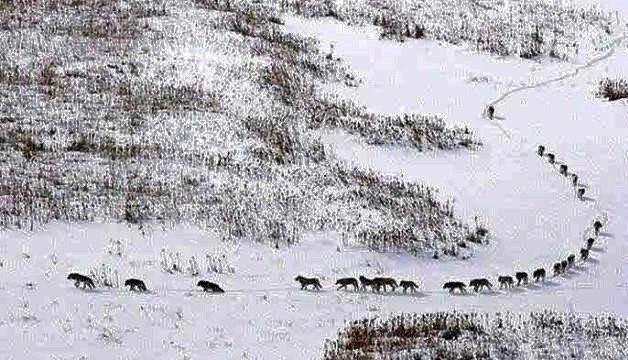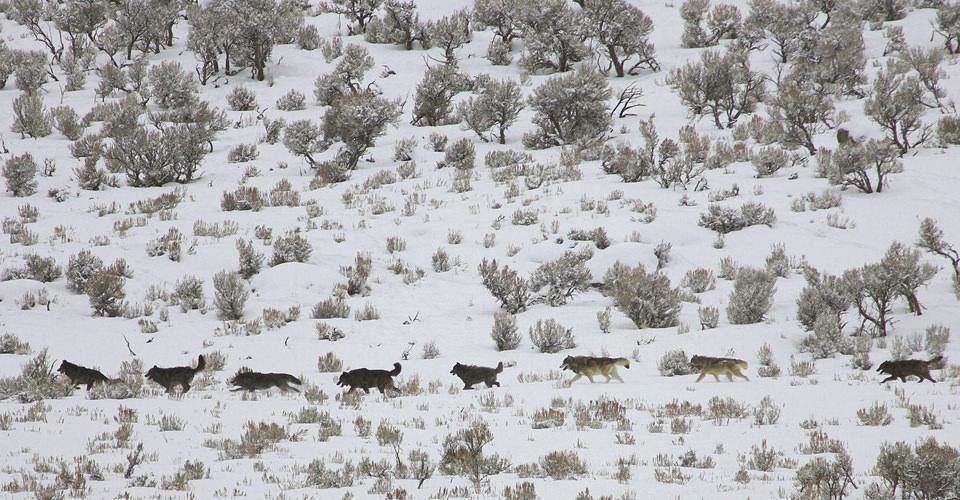The first image is the image on the left, the second image is the image on the right. For the images displayed, is the sentence "The right image contains exactly one wolf." factually correct? Answer yes or no. No. The first image is the image on the left, the second image is the image on the right. Assess this claim about the two images: "Wolves are walking leftward in a straight line across snow-covered ground in one image.". Correct or not? Answer yes or no. Yes. 